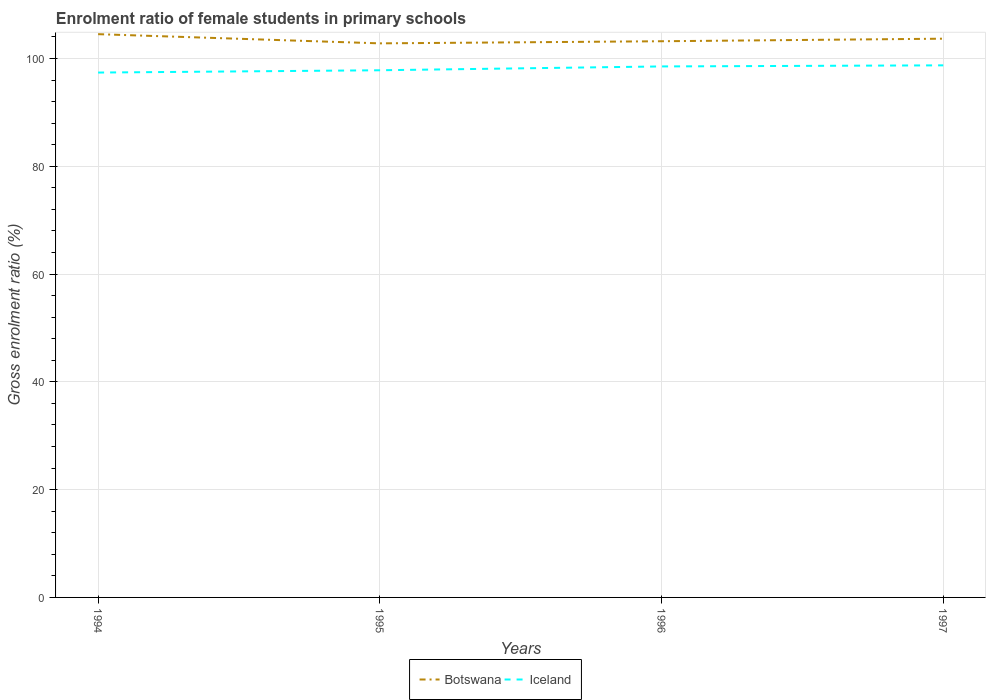How many different coloured lines are there?
Give a very brief answer. 2. Is the number of lines equal to the number of legend labels?
Offer a very short reply. Yes. Across all years, what is the maximum enrolment ratio of female students in primary schools in Botswana?
Provide a succinct answer. 102.8. What is the total enrolment ratio of female students in primary schools in Botswana in the graph?
Provide a short and direct response. -0.47. What is the difference between the highest and the second highest enrolment ratio of female students in primary schools in Iceland?
Your answer should be compact. 1.34. How many lines are there?
Offer a very short reply. 2. How many years are there in the graph?
Offer a terse response. 4. What is the difference between two consecutive major ticks on the Y-axis?
Keep it short and to the point. 20. Where does the legend appear in the graph?
Ensure brevity in your answer.  Bottom center. How many legend labels are there?
Offer a very short reply. 2. What is the title of the graph?
Ensure brevity in your answer.  Enrolment ratio of female students in primary schools. What is the label or title of the X-axis?
Your response must be concise. Years. What is the label or title of the Y-axis?
Your response must be concise. Gross enrolment ratio (%). What is the Gross enrolment ratio (%) in Botswana in 1994?
Provide a short and direct response. 104.51. What is the Gross enrolment ratio (%) in Iceland in 1994?
Make the answer very short. 97.39. What is the Gross enrolment ratio (%) in Botswana in 1995?
Provide a short and direct response. 102.8. What is the Gross enrolment ratio (%) of Iceland in 1995?
Provide a succinct answer. 97.81. What is the Gross enrolment ratio (%) in Botswana in 1996?
Your response must be concise. 103.2. What is the Gross enrolment ratio (%) of Iceland in 1996?
Your answer should be compact. 98.52. What is the Gross enrolment ratio (%) of Botswana in 1997?
Make the answer very short. 103.67. What is the Gross enrolment ratio (%) of Iceland in 1997?
Your answer should be compact. 98.73. Across all years, what is the maximum Gross enrolment ratio (%) of Botswana?
Give a very brief answer. 104.51. Across all years, what is the maximum Gross enrolment ratio (%) in Iceland?
Your response must be concise. 98.73. Across all years, what is the minimum Gross enrolment ratio (%) in Botswana?
Your response must be concise. 102.8. Across all years, what is the minimum Gross enrolment ratio (%) in Iceland?
Make the answer very short. 97.39. What is the total Gross enrolment ratio (%) in Botswana in the graph?
Your response must be concise. 414.18. What is the total Gross enrolment ratio (%) of Iceland in the graph?
Your answer should be very brief. 392.45. What is the difference between the Gross enrolment ratio (%) in Botswana in 1994 and that in 1995?
Offer a terse response. 1.71. What is the difference between the Gross enrolment ratio (%) of Iceland in 1994 and that in 1995?
Ensure brevity in your answer.  -0.43. What is the difference between the Gross enrolment ratio (%) of Botswana in 1994 and that in 1996?
Your answer should be very brief. 1.31. What is the difference between the Gross enrolment ratio (%) of Iceland in 1994 and that in 1996?
Your answer should be very brief. -1.14. What is the difference between the Gross enrolment ratio (%) in Botswana in 1994 and that in 1997?
Provide a short and direct response. 0.84. What is the difference between the Gross enrolment ratio (%) of Iceland in 1994 and that in 1997?
Ensure brevity in your answer.  -1.34. What is the difference between the Gross enrolment ratio (%) in Botswana in 1995 and that in 1996?
Give a very brief answer. -0.39. What is the difference between the Gross enrolment ratio (%) of Iceland in 1995 and that in 1996?
Your answer should be very brief. -0.71. What is the difference between the Gross enrolment ratio (%) in Botswana in 1995 and that in 1997?
Give a very brief answer. -0.87. What is the difference between the Gross enrolment ratio (%) in Iceland in 1995 and that in 1997?
Your response must be concise. -0.91. What is the difference between the Gross enrolment ratio (%) in Botswana in 1996 and that in 1997?
Make the answer very short. -0.47. What is the difference between the Gross enrolment ratio (%) of Iceland in 1996 and that in 1997?
Make the answer very short. -0.2. What is the difference between the Gross enrolment ratio (%) in Botswana in 1994 and the Gross enrolment ratio (%) in Iceland in 1995?
Provide a succinct answer. 6.7. What is the difference between the Gross enrolment ratio (%) of Botswana in 1994 and the Gross enrolment ratio (%) of Iceland in 1996?
Provide a short and direct response. 5.99. What is the difference between the Gross enrolment ratio (%) of Botswana in 1994 and the Gross enrolment ratio (%) of Iceland in 1997?
Offer a terse response. 5.78. What is the difference between the Gross enrolment ratio (%) in Botswana in 1995 and the Gross enrolment ratio (%) in Iceland in 1996?
Your answer should be very brief. 4.28. What is the difference between the Gross enrolment ratio (%) in Botswana in 1995 and the Gross enrolment ratio (%) in Iceland in 1997?
Offer a very short reply. 4.08. What is the difference between the Gross enrolment ratio (%) of Botswana in 1996 and the Gross enrolment ratio (%) of Iceland in 1997?
Offer a terse response. 4.47. What is the average Gross enrolment ratio (%) of Botswana per year?
Provide a succinct answer. 103.55. What is the average Gross enrolment ratio (%) in Iceland per year?
Provide a succinct answer. 98.11. In the year 1994, what is the difference between the Gross enrolment ratio (%) of Botswana and Gross enrolment ratio (%) of Iceland?
Give a very brief answer. 7.12. In the year 1995, what is the difference between the Gross enrolment ratio (%) of Botswana and Gross enrolment ratio (%) of Iceland?
Keep it short and to the point. 4.99. In the year 1996, what is the difference between the Gross enrolment ratio (%) of Botswana and Gross enrolment ratio (%) of Iceland?
Provide a succinct answer. 4.67. In the year 1997, what is the difference between the Gross enrolment ratio (%) in Botswana and Gross enrolment ratio (%) in Iceland?
Your answer should be very brief. 4.95. What is the ratio of the Gross enrolment ratio (%) of Botswana in 1994 to that in 1995?
Offer a terse response. 1.02. What is the ratio of the Gross enrolment ratio (%) in Botswana in 1994 to that in 1996?
Provide a succinct answer. 1.01. What is the ratio of the Gross enrolment ratio (%) of Iceland in 1994 to that in 1996?
Your response must be concise. 0.99. What is the ratio of the Gross enrolment ratio (%) in Iceland in 1994 to that in 1997?
Offer a terse response. 0.99. What is the ratio of the Gross enrolment ratio (%) of Botswana in 1995 to that in 1996?
Offer a very short reply. 1. What is the ratio of the Gross enrolment ratio (%) in Iceland in 1995 to that in 1996?
Give a very brief answer. 0.99. What is the ratio of the Gross enrolment ratio (%) of Botswana in 1995 to that in 1997?
Offer a terse response. 0.99. What is the ratio of the Gross enrolment ratio (%) of Iceland in 1995 to that in 1997?
Provide a succinct answer. 0.99. What is the ratio of the Gross enrolment ratio (%) of Botswana in 1996 to that in 1997?
Your answer should be very brief. 1. What is the difference between the highest and the second highest Gross enrolment ratio (%) in Botswana?
Your answer should be compact. 0.84. What is the difference between the highest and the second highest Gross enrolment ratio (%) in Iceland?
Offer a very short reply. 0.2. What is the difference between the highest and the lowest Gross enrolment ratio (%) of Botswana?
Offer a terse response. 1.71. What is the difference between the highest and the lowest Gross enrolment ratio (%) of Iceland?
Your answer should be very brief. 1.34. 